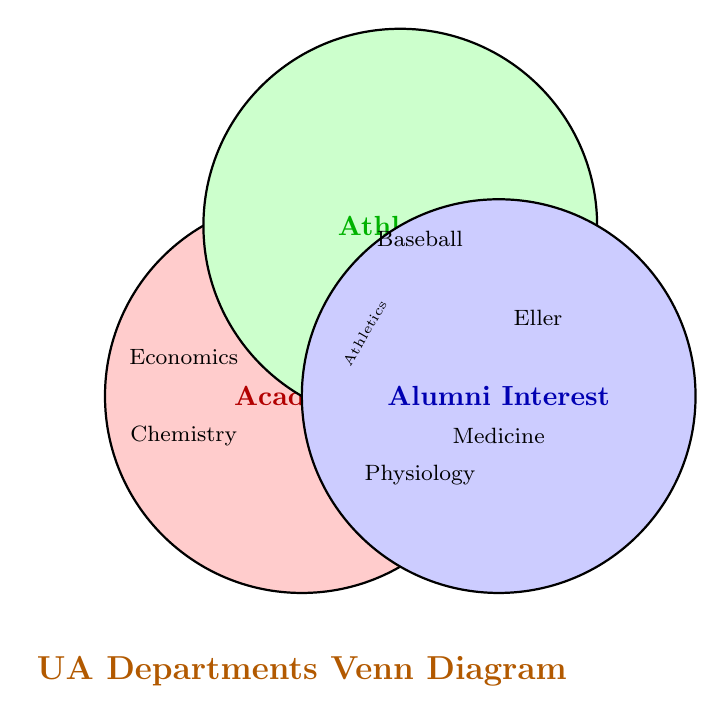Which department is represented in the Academic circle but not in Alumni Interest or Athletics? The department within the Academic circle and not overlapping with Alumni Interest or Athletics is only included in the Academic section.
Answer: Economics, Chemistry, Engineering, History, Science Which departments are in the Alumni Interest circle only? Look at the section where only the Alumni Interest circle is not overlapping with any other circle.
Answer: Eller College of Management Which areas intersect between Alumni Interest and Athletics but not with Academics? Look at the overlap between Alumni Interest and Athletics that excludes the Academic circle.
Answer: Intercollegiate Athletics, Baseball Program What overlaps do you see among Academic, Alumni Interest, and Athletics? This refers to where all three circles intersect.
Answer: Physiology, College of Medicine Which department is indicated at the very center, intersecting all three circles? The center of the Venn Diagram, where all three circles intersect, indicates the departments of interest in all categories.
Answer: None What department does the Academic and Alumni Interest categories share, excluding Athletics? Look at the intersection of Academic and Alumni Interest circles without including the Athletics circle.
Answer: Eller College of Management Which is the only area that intersects between Academics and Athletics? Identify the overlap between the Academics and Athletics circles without an intersection with Alumni Interest.
Answer: There is no such area List departments that fall exclusively into the Academic circle. Identify departments inside the Academic circle that do not touch the other circles.
Answer: Economics, Chemistry, Engineering, History, Science 